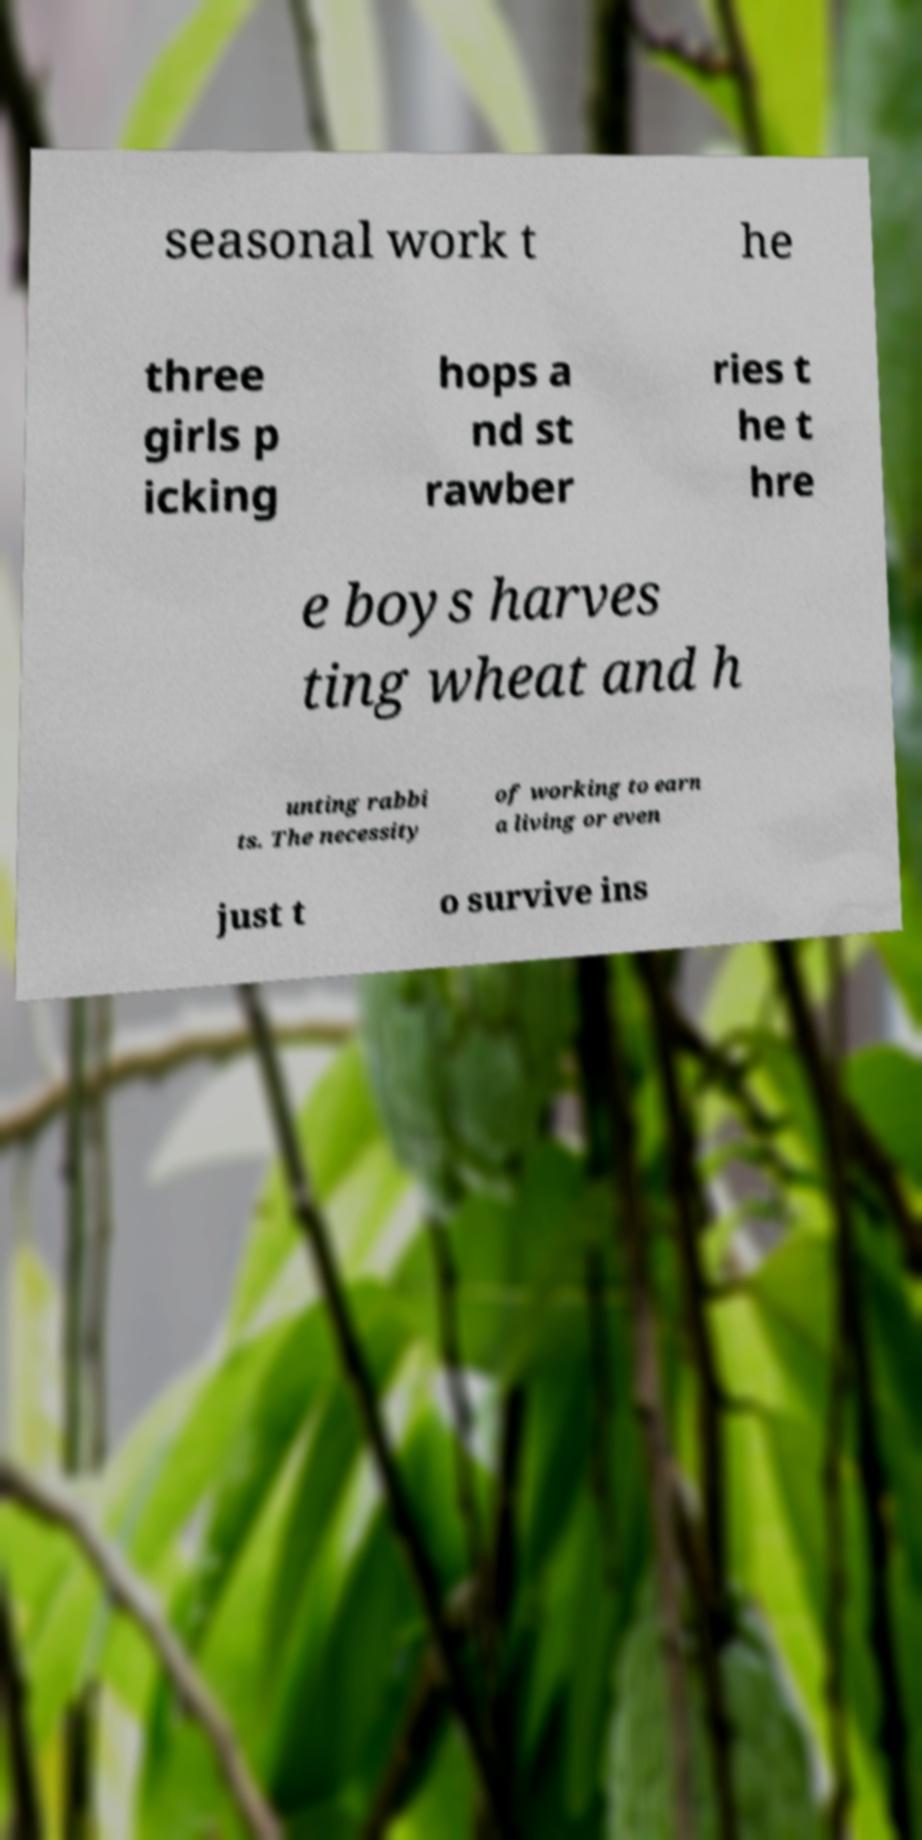Could you assist in decoding the text presented in this image and type it out clearly? seasonal work t he three girls p icking hops a nd st rawber ries t he t hre e boys harves ting wheat and h unting rabbi ts. The necessity of working to earn a living or even just t o survive ins 